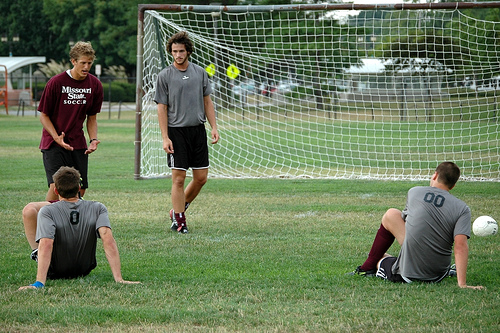<image>
Is the person in the net? No. The person is not contained within the net. These objects have a different spatial relationship. Is the man red next to the man blue? Yes. The man red is positioned adjacent to the man blue, located nearby in the same general area. 